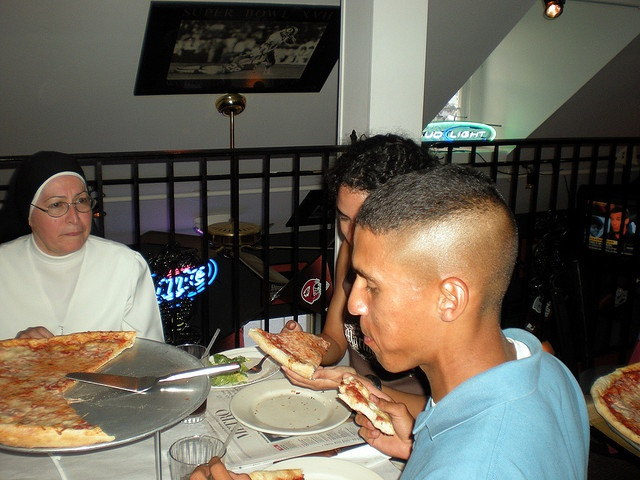Describe the objects in this image and their specific colors. I can see people in gray, tan, lightblue, darkgray, and black tones, people in gray, beige, lightgray, black, and brown tones, people in gray, black, maroon, salmon, and brown tones, pizza in gray, brown, and tan tones, and tv in gray, black, maroon, and brown tones in this image. 